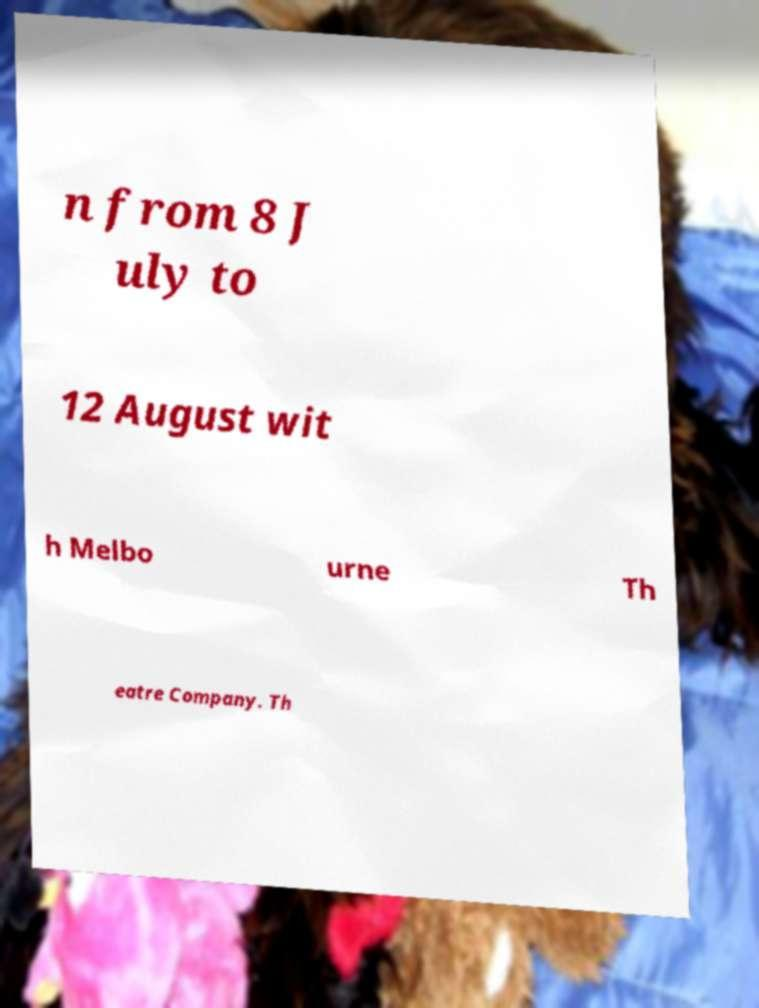Could you extract and type out the text from this image? n from 8 J uly to 12 August wit h Melbo urne Th eatre Company. Th 